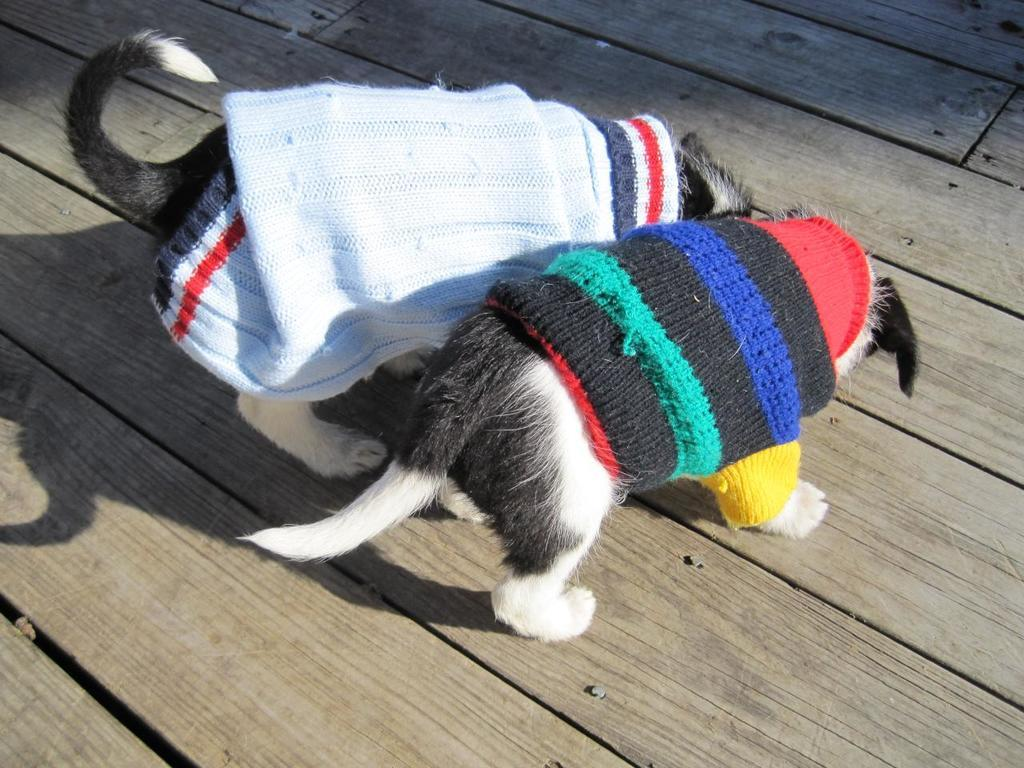What animals are in the foreground of the image? There are two dogs in the foreground of the image. What are the dogs wearing? The dogs are wearing clothes. What type of surface are the dogs standing on? The dogs are standing on a wooden surface. How many pigs are visible in the image? There are no pigs present in the image; it features two dogs wearing clothes. 